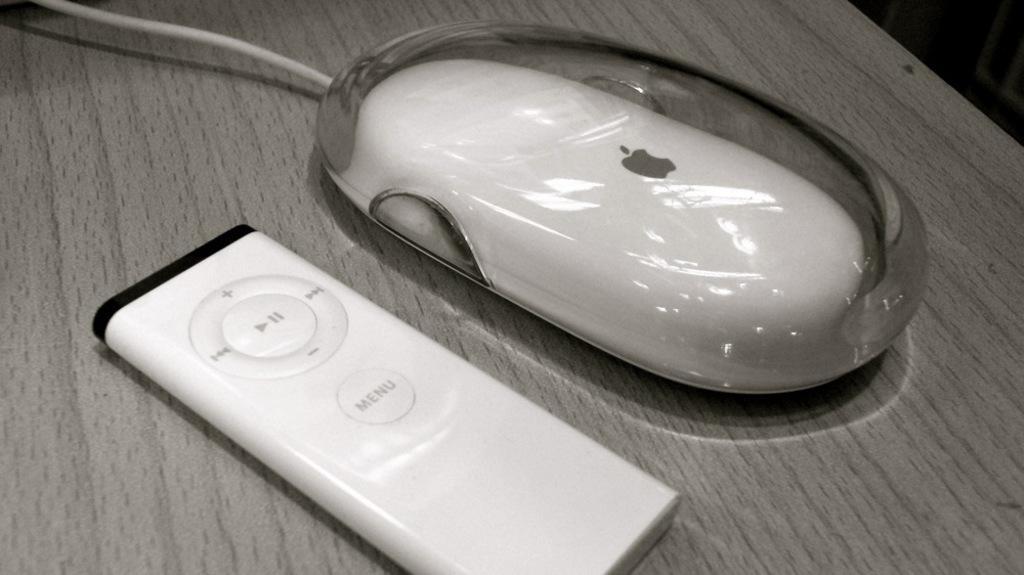Can you describe this image briefly? In this image I can see a mouse and a remote on the table and the table is in gray color. 